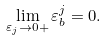Convert formula to latex. <formula><loc_0><loc_0><loc_500><loc_500>\lim _ { \varepsilon _ { j } \rightarrow 0 + } \varepsilon _ { b } ^ { j } = 0 .</formula> 